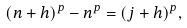Convert formula to latex. <formula><loc_0><loc_0><loc_500><loc_500>( n + h ) ^ { p } - n ^ { p } = ( j + h ) ^ { p } ,</formula> 